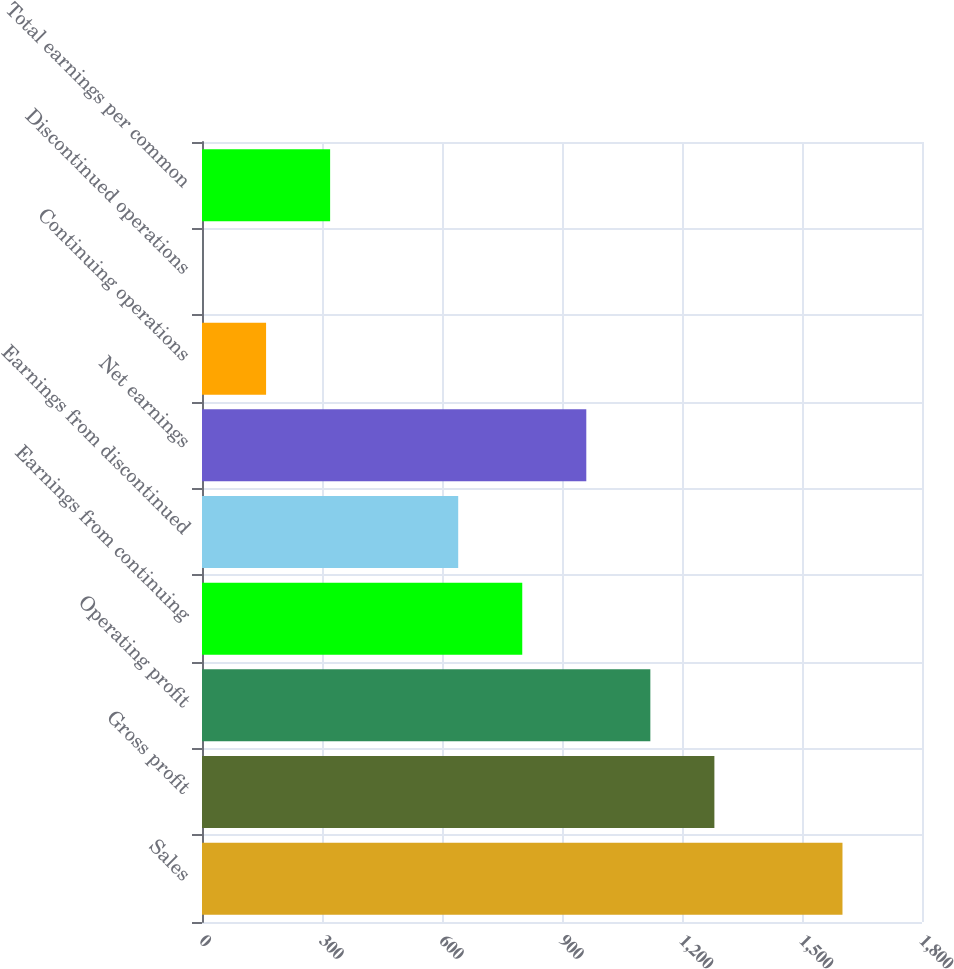<chart> <loc_0><loc_0><loc_500><loc_500><bar_chart><fcel>Sales<fcel>Gross profit<fcel>Operating profit<fcel>Earnings from continuing<fcel>Earnings from discontinued<fcel>Net earnings<fcel>Continuing operations<fcel>Discontinued operations<fcel>Total earnings per common<nl><fcel>1601.2<fcel>1280.97<fcel>1120.86<fcel>800.64<fcel>640.53<fcel>960.75<fcel>160.2<fcel>0.09<fcel>320.31<nl></chart> 